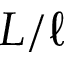Convert formula to latex. <formula><loc_0><loc_0><loc_500><loc_500>L / \ell</formula> 